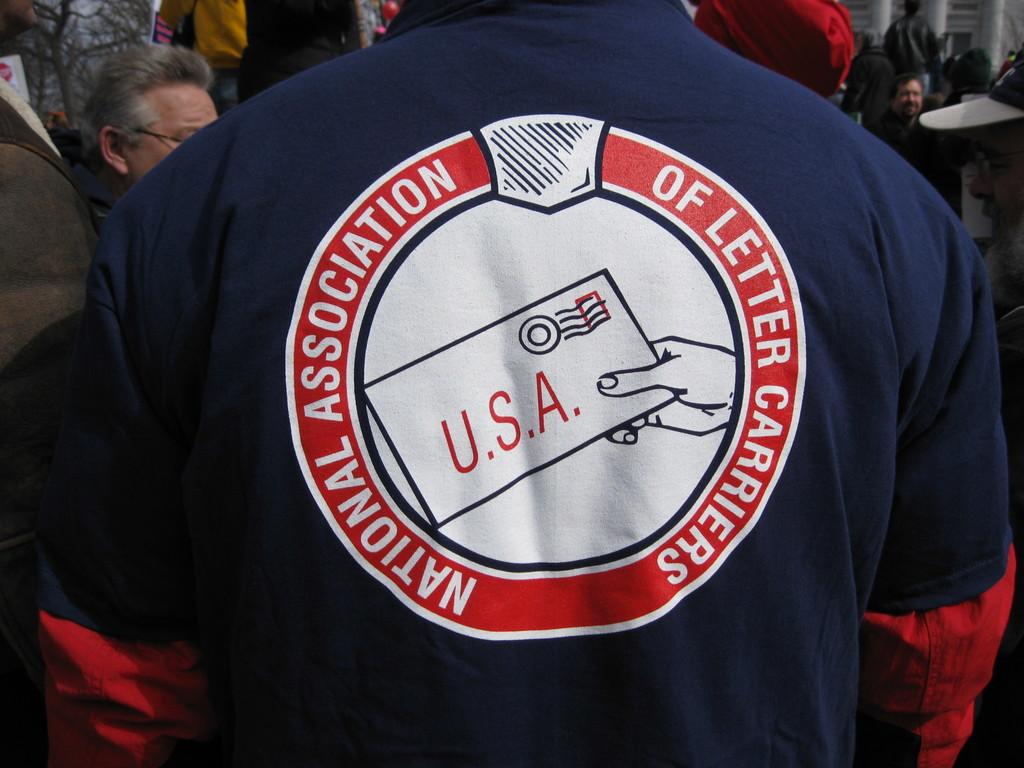What country is represented on the envelope?
Offer a very short reply. Usa. What association is this shirt advertising?
Give a very brief answer. National association of letter carriers. 